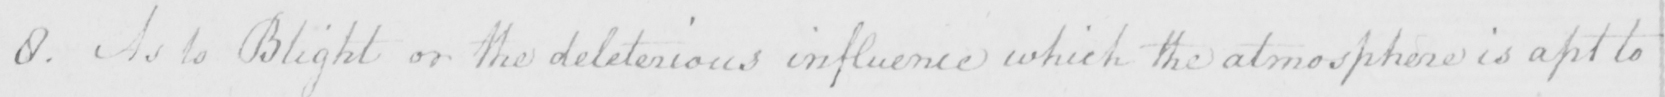What does this handwritten line say? 8 . As to Blight or the deleterious influence which the atmosphere is apt to 